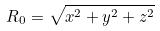Convert formula to latex. <formula><loc_0><loc_0><loc_500><loc_500>R _ { 0 } = \sqrt { x ^ { 2 } + y ^ { 2 } + z ^ { 2 } }</formula> 